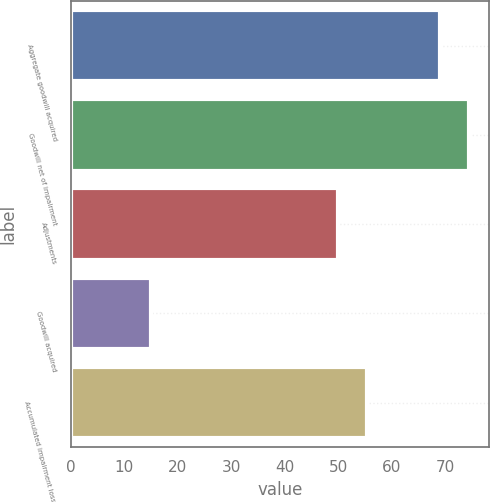Convert chart to OTSL. <chart><loc_0><loc_0><loc_500><loc_500><bar_chart><fcel>Aggregate goodwill acquired<fcel>Goodwill net of impairment<fcel>Adjustments<fcel>Goodwill acquired<fcel>Accumulated impairment losses<nl><fcel>69<fcel>74.4<fcel>50<fcel>15<fcel>55.4<nl></chart> 